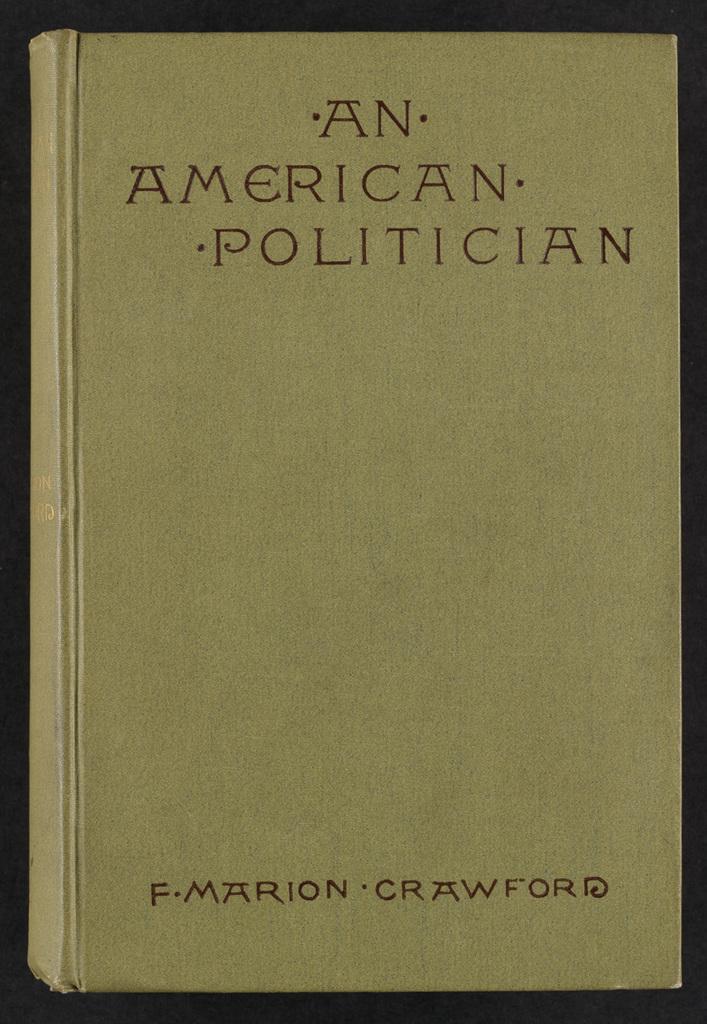What is the title of this book?
Give a very brief answer. An american politician. 